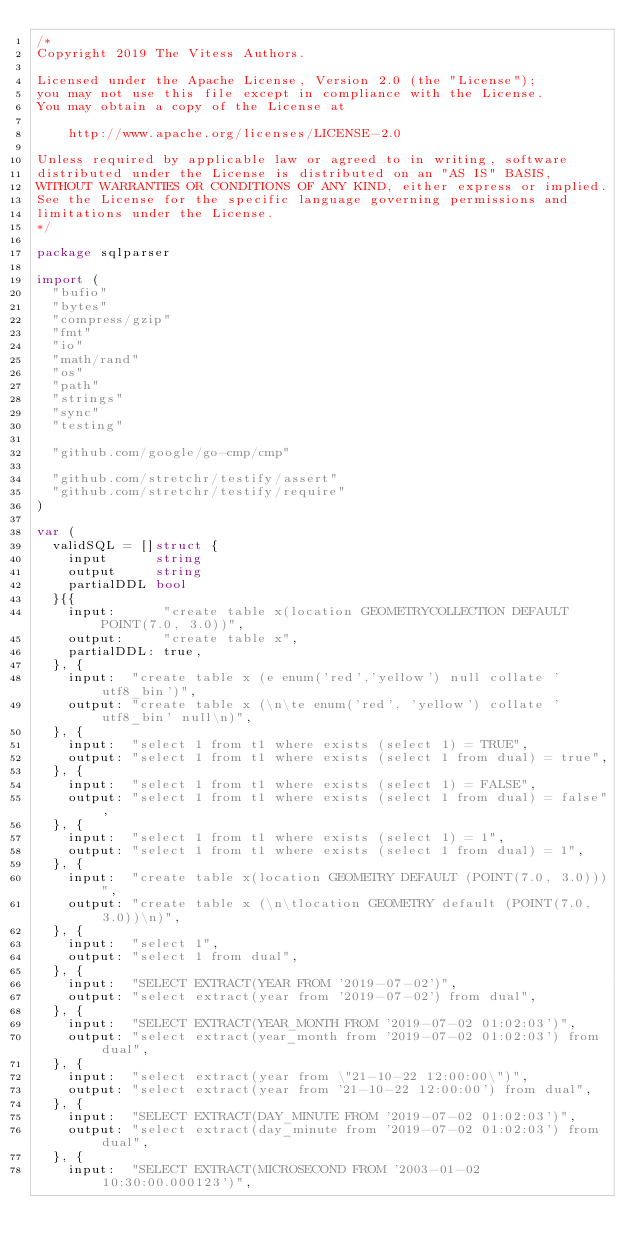Convert code to text. <code><loc_0><loc_0><loc_500><loc_500><_Go_>/*
Copyright 2019 The Vitess Authors.

Licensed under the Apache License, Version 2.0 (the "License");
you may not use this file except in compliance with the License.
You may obtain a copy of the License at

    http://www.apache.org/licenses/LICENSE-2.0

Unless required by applicable law or agreed to in writing, software
distributed under the License is distributed on an "AS IS" BASIS,
WITHOUT WARRANTIES OR CONDITIONS OF ANY KIND, either express or implied.
See the License for the specific language governing permissions and
limitations under the License.
*/

package sqlparser

import (
	"bufio"
	"bytes"
	"compress/gzip"
	"fmt"
	"io"
	"math/rand"
	"os"
	"path"
	"strings"
	"sync"
	"testing"

	"github.com/google/go-cmp/cmp"

	"github.com/stretchr/testify/assert"
	"github.com/stretchr/testify/require"
)

var (
	validSQL = []struct {
		input      string
		output     string
		partialDDL bool
	}{{
		input:      "create table x(location GEOMETRYCOLLECTION DEFAULT POINT(7.0, 3.0))",
		output:     "create table x",
		partialDDL: true,
	}, {
		input:  "create table x (e enum('red','yellow') null collate 'utf8_bin')",
		output: "create table x (\n\te enum('red', 'yellow') collate 'utf8_bin' null\n)",
	}, {
		input:  "select 1 from t1 where exists (select 1) = TRUE",
		output: "select 1 from t1 where exists (select 1 from dual) = true",
	}, {
		input:  "select 1 from t1 where exists (select 1) = FALSE",
		output: "select 1 from t1 where exists (select 1 from dual) = false",
	}, {
		input:  "select 1 from t1 where exists (select 1) = 1",
		output: "select 1 from t1 where exists (select 1 from dual) = 1",
	}, {
		input:  "create table x(location GEOMETRY DEFAULT (POINT(7.0, 3.0)))",
		output: "create table x (\n\tlocation GEOMETRY default (POINT(7.0, 3.0))\n)",
	}, {
		input:  "select 1",
		output: "select 1 from dual",
	}, {
		input:  "SELECT EXTRACT(YEAR FROM '2019-07-02')",
		output: "select extract(year from '2019-07-02') from dual",
	}, {
		input:  "SELECT EXTRACT(YEAR_MONTH FROM '2019-07-02 01:02:03')",
		output: "select extract(year_month from '2019-07-02 01:02:03') from dual",
	}, {
		input:  "select extract(year from \"21-10-22 12:00:00\")",
		output: "select extract(year from '21-10-22 12:00:00') from dual",
	}, {
		input:  "SELECT EXTRACT(DAY_MINUTE FROM '2019-07-02 01:02:03')",
		output: "select extract(day_minute from '2019-07-02 01:02:03') from dual",
	}, {
		input:  "SELECT EXTRACT(MICROSECOND FROM '2003-01-02 10:30:00.000123')",</code> 